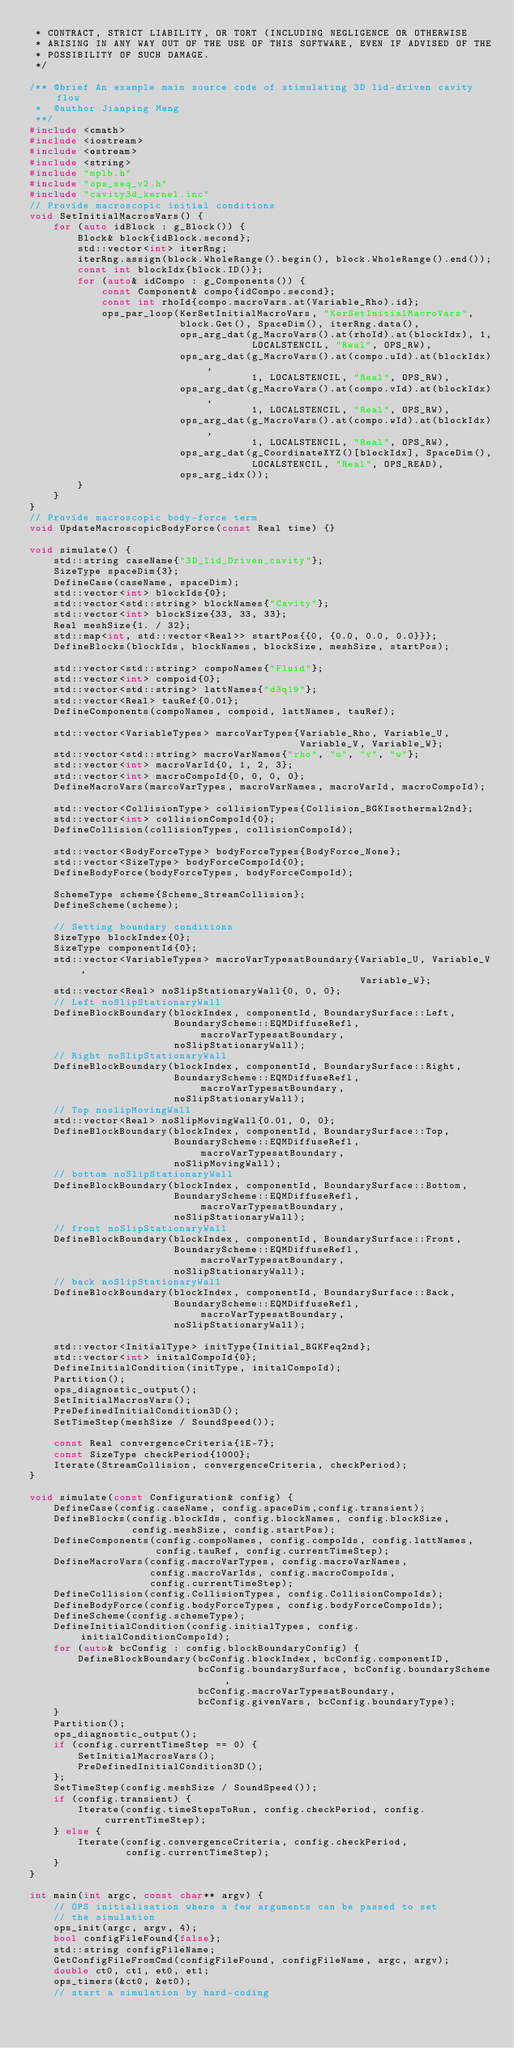Convert code to text. <code><loc_0><loc_0><loc_500><loc_500><_C++_> * CONTRACT, STRICT LIABILITY, OR TORT (INCLUDING NEGLIGENCE OR OTHERWISE
 * ARISING IN ANY WAY OUT OF THE USE OF THIS SOFTWARE, EVEN IF ADVISED OF THE
 * POSSIBILITY OF SUCH DAMAGE.
 */

/** @brief An example main source code of stimulating 3D lid-driven cavity flow
 *  @author Jianping Meng
 **/
#include <cmath>
#include <iostream>
#include <ostream>
#include <string>
#include "mplb.h"
#include "ops_seq_v2.h"
#include "cavity3d_kernel.inc"
// Provide macroscopic initial conditions
void SetInitialMacrosVars() {
    for (auto idBlock : g_Block()) {
        Block& block{idBlock.second};
        std::vector<int> iterRng;
        iterRng.assign(block.WholeRange().begin(), block.WholeRange().end());
        const int blockIdx{block.ID()};
        for (auto& idCompo : g_Components()) {
            const Component& compo{idCompo.second};
            const int rhoId{compo.macroVars.at(Variable_Rho).id};
            ops_par_loop(KerSetInitialMacroVars, "KerSetInitialMacroVars",
                         block.Get(), SpaceDim(), iterRng.data(),
                         ops_arg_dat(g_MacroVars().at(rhoId).at(blockIdx), 1,
                                     LOCALSTENCIL, "Real", OPS_RW),
                         ops_arg_dat(g_MacroVars().at(compo.uId).at(blockIdx),
                                     1, LOCALSTENCIL, "Real", OPS_RW),
                         ops_arg_dat(g_MacroVars().at(compo.vId).at(blockIdx),
                                     1, LOCALSTENCIL, "Real", OPS_RW),
                         ops_arg_dat(g_MacroVars().at(compo.wId).at(blockIdx),
                                     1, LOCALSTENCIL, "Real", OPS_RW),
                         ops_arg_dat(g_CoordinateXYZ()[blockIdx], SpaceDim(),
                                     LOCALSTENCIL, "Real", OPS_READ),
                         ops_arg_idx());
        }
    }
}
// Provide macroscopic body-force term
void UpdateMacroscopicBodyForce(const Real time) {}

void simulate() {
    std::string caseName{"3D_lid_Driven_cavity"};
    SizeType spaceDim{3};
    DefineCase(caseName, spaceDim);
    std::vector<int> blockIds{0};
    std::vector<std::string> blockNames{"Cavity"};
    std::vector<int> blockSize{33, 33, 33};
    Real meshSize{1. / 32};
    std::map<int, std::vector<Real>> startPos{{0, {0.0, 0.0, 0.0}}};
    DefineBlocks(blockIds, blockNames, blockSize, meshSize, startPos);

    std::vector<std::string> compoNames{"Fluid"};
    std::vector<int> compoid{0};
    std::vector<std::string> lattNames{"d3q19"};
    std::vector<Real> tauRef{0.01};
    DefineComponents(compoNames, compoid, lattNames, tauRef);

    std::vector<VariableTypes> marcoVarTypes{Variable_Rho, Variable_U,
                                             Variable_V, Variable_W};
    std::vector<std::string> macroVarNames{"rho", "u", "v", "w"};
    std::vector<int> macroVarId{0, 1, 2, 3};
    std::vector<int> macroCompoId{0, 0, 0, 0};
    DefineMacroVars(marcoVarTypes, macroVarNames, macroVarId, macroCompoId);

    std::vector<CollisionType> collisionTypes{Collision_BGKIsothermal2nd};
    std::vector<int> collisionCompoId{0};
    DefineCollision(collisionTypes, collisionCompoId);

    std::vector<BodyForceType> bodyForceTypes{BodyForce_None};
    std::vector<SizeType> bodyForceCompoId{0};
    DefineBodyForce(bodyForceTypes, bodyForceCompoId);

    SchemeType scheme{Scheme_StreamCollision};
    DefineScheme(scheme);

    // Setting boundary conditions
    SizeType blockIndex{0};
    SizeType componentId{0};
    std::vector<VariableTypes> macroVarTypesatBoundary{Variable_U, Variable_V,
                                                       Variable_W};
    std::vector<Real> noSlipStationaryWall{0, 0, 0};
    // Left noSlipStationaryWall
    DefineBlockBoundary(blockIndex, componentId, BoundarySurface::Left,
                        BoundaryScheme::EQMDiffuseRefl, macroVarTypesatBoundary,
                        noSlipStationaryWall);
    // Right noSlipStationaryWall
    DefineBlockBoundary(blockIndex, componentId, BoundarySurface::Right,
                        BoundaryScheme::EQMDiffuseRefl, macroVarTypesatBoundary,
                        noSlipStationaryWall);
    // Top noslipMovingWall
    std::vector<Real> noSlipMovingWall{0.01, 0, 0};
    DefineBlockBoundary(blockIndex, componentId, BoundarySurface::Top,
                        BoundaryScheme::EQMDiffuseRefl, macroVarTypesatBoundary,
                        noSlipMovingWall);
    // bottom noSlipStationaryWall
    DefineBlockBoundary(blockIndex, componentId, BoundarySurface::Bottom,
                        BoundaryScheme::EQMDiffuseRefl, macroVarTypesatBoundary,
                        noSlipStationaryWall);
    // front noSlipStationaryWall
    DefineBlockBoundary(blockIndex, componentId, BoundarySurface::Front,
                        BoundaryScheme::EQMDiffuseRefl, macroVarTypesatBoundary,
                        noSlipStationaryWall);
    // back noSlipStationaryWall
    DefineBlockBoundary(blockIndex, componentId, BoundarySurface::Back,
                        BoundaryScheme::EQMDiffuseRefl, macroVarTypesatBoundary,
                        noSlipStationaryWall);

    std::vector<InitialType> initType{Initial_BGKFeq2nd};
    std::vector<int> initalCompoId{0};
    DefineInitialCondition(initType, initalCompoId);
    Partition();
    ops_diagnostic_output();
    SetInitialMacrosVars();
    PreDefinedInitialCondition3D();
    SetTimeStep(meshSize / SoundSpeed());

    const Real convergenceCriteria{1E-7};
    const SizeType checkPeriod{1000};
    Iterate(StreamCollision, convergenceCriteria, checkPeriod);
}

void simulate(const Configuration& config) {
    DefineCase(config.caseName, config.spaceDim,config.transient);
    DefineBlocks(config.blockIds, config.blockNames, config.blockSize,
                 config.meshSize, config.startPos);
    DefineComponents(config.compoNames, config.compoIds, config.lattNames,
                     config.tauRef, config.currentTimeStep);
    DefineMacroVars(config.macroVarTypes, config.macroVarNames,
                    config.macroVarIds, config.macroCompoIds,
                    config.currentTimeStep);
    DefineCollision(config.CollisionTypes, config.CollisionCompoIds);
    DefineBodyForce(config.bodyForceTypes, config.bodyForceCompoIds);
    DefineScheme(config.schemeType);
    DefineInitialCondition(config.initialTypes, config.initialConditionCompoId);
    for (auto& bcConfig : config.blockBoundaryConfig) {
        DefineBlockBoundary(bcConfig.blockIndex, bcConfig.componentID,
                            bcConfig.boundarySurface, bcConfig.boundaryScheme,
                            bcConfig.macroVarTypesatBoundary,
                            bcConfig.givenVars, bcConfig.boundaryType);
    }
    Partition();
    ops_diagnostic_output();
    if (config.currentTimeStep == 0) {
        SetInitialMacrosVars();
        PreDefinedInitialCondition3D();
    };
    SetTimeStep(config.meshSize / SoundSpeed());
    if (config.transient) {
        Iterate(config.timeStepsToRun, config.checkPeriod, config.currentTimeStep);
    } else {
        Iterate(config.convergenceCriteria, config.checkPeriod,
                config.currentTimeStep);
    }
}

int main(int argc, const char** argv) {
    // OPS initialisation where a few arguments can be passed to set
    // the simulation
    ops_init(argc, argv, 4);
    bool configFileFound{false};
    std::string configFileName;
    GetConfigFileFromCmd(configFileFound, configFileName, argc, argv);
    double ct0, ct1, et0, et1;
    ops_timers(&ct0, &et0);
    // start a simulation by hard-coding</code> 